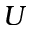<formula> <loc_0><loc_0><loc_500><loc_500>U</formula> 